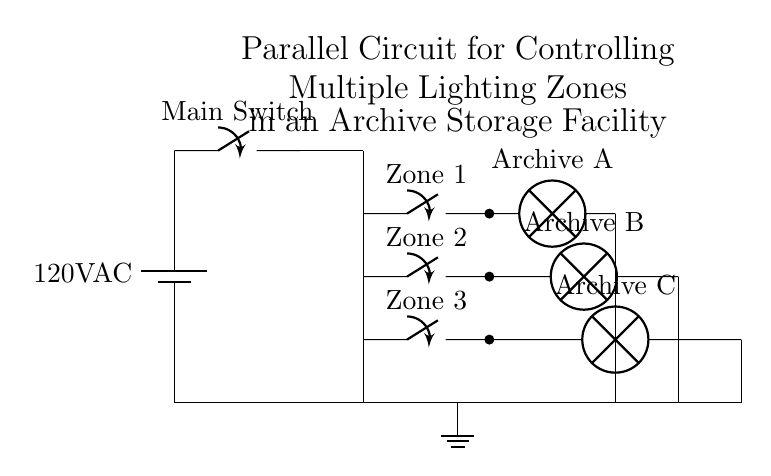What is the voltage of this circuit? The circuit is powered by a 120V AC battery, which indicates the voltage supplied to the circuit components.
Answer: 120V AC How many lighting zones are there? The circuit diagram shows three distinct zones, each controlled by its own switch, indicating the number of lighting zones in the archive storage facility.
Answer: Three What is the function of the main switch? The main switch is used to control the power flow from the battery to the entire circuit; it allows the user to turn all zones on or off simultaneously.
Answer: Control power flow Which zone corresponds to Archive A? Archive A is linked to Zone 1, which is indicated by the label in the circuit relating the lamp directly to its respective switch within the first zone.
Answer: Zone 1 If Zone 2 is switched off, what happens to the other zones? Since this is a parallel circuit, if Zone 2 is switched off, Zones 1 and 3 will continue to function independently of Zone 2, allowing their lamps to remain lit.
Answer: Zones 1 and 3 remain functional What type of circuit is used in this diagram? The circuit is a parallel circuit, as indicated by the layout where each zone is connected independently to the main distribution line, allowing simultaneous operation of multiple loads.
Answer: Parallel circuit 